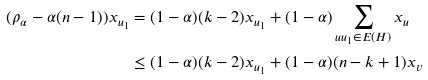Convert formula to latex. <formula><loc_0><loc_0><loc_500><loc_500>( \rho _ { \alpha } - \alpha ( n - 1 ) ) x _ { u _ { 1 } } & = ( 1 - \alpha ) ( k - 2 ) x _ { u _ { 1 } } + ( 1 - \alpha ) \sum _ { u u _ { 1 } \in E ( H ) } x _ { u } \\ & \leq ( 1 - \alpha ) ( k - 2 ) x _ { u _ { 1 } } + ( 1 - \alpha ) ( n - k + 1 ) x _ { v }</formula> 